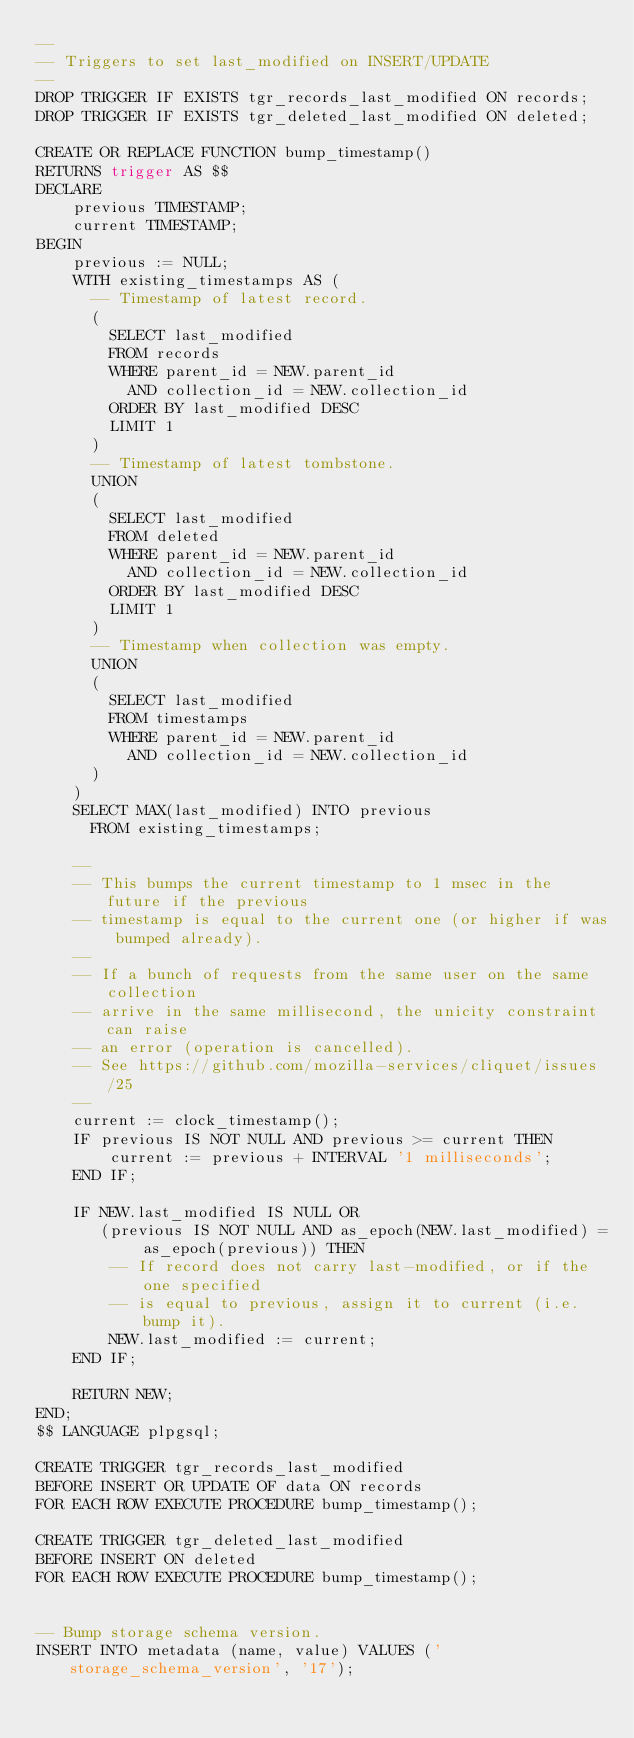<code> <loc_0><loc_0><loc_500><loc_500><_SQL_>--
-- Triggers to set last_modified on INSERT/UPDATE
--
DROP TRIGGER IF EXISTS tgr_records_last_modified ON records;
DROP TRIGGER IF EXISTS tgr_deleted_last_modified ON deleted;

CREATE OR REPLACE FUNCTION bump_timestamp()
RETURNS trigger AS $$
DECLARE
    previous TIMESTAMP;
    current TIMESTAMP;
BEGIN
    previous := NULL;
    WITH existing_timestamps AS (
      -- Timestamp of latest record.
      (
        SELECT last_modified
        FROM records
        WHERE parent_id = NEW.parent_id
          AND collection_id = NEW.collection_id
        ORDER BY last_modified DESC
        LIMIT 1
      )
      -- Timestamp of latest tombstone.
      UNION
      (
        SELECT last_modified
        FROM deleted
        WHERE parent_id = NEW.parent_id
          AND collection_id = NEW.collection_id
        ORDER BY last_modified DESC
        LIMIT 1
      )
      -- Timestamp when collection was empty.
      UNION
      (
        SELECT last_modified
        FROM timestamps
        WHERE parent_id = NEW.parent_id
          AND collection_id = NEW.collection_id
      )
    )
    SELECT MAX(last_modified) INTO previous
      FROM existing_timestamps;

    --
    -- This bumps the current timestamp to 1 msec in the future if the previous
    -- timestamp is equal to the current one (or higher if was bumped already).
    --
    -- If a bunch of requests from the same user on the same collection
    -- arrive in the same millisecond, the unicity constraint can raise
    -- an error (operation is cancelled).
    -- See https://github.com/mozilla-services/cliquet/issues/25
    --
    current := clock_timestamp();
    IF previous IS NOT NULL AND previous >= current THEN
        current := previous + INTERVAL '1 milliseconds';
    END IF;

    IF NEW.last_modified IS NULL OR
       (previous IS NOT NULL AND as_epoch(NEW.last_modified) = as_epoch(previous)) THEN
        -- If record does not carry last-modified, or if the one specified
        -- is equal to previous, assign it to current (i.e. bump it).
        NEW.last_modified := current;
    END IF;

    RETURN NEW;
END;
$$ LANGUAGE plpgsql;

CREATE TRIGGER tgr_records_last_modified
BEFORE INSERT OR UPDATE OF data ON records
FOR EACH ROW EXECUTE PROCEDURE bump_timestamp();

CREATE TRIGGER tgr_deleted_last_modified
BEFORE INSERT ON deleted
FOR EACH ROW EXECUTE PROCEDURE bump_timestamp();


-- Bump storage schema version.
INSERT INTO metadata (name, value) VALUES ('storage_schema_version', '17');
</code> 